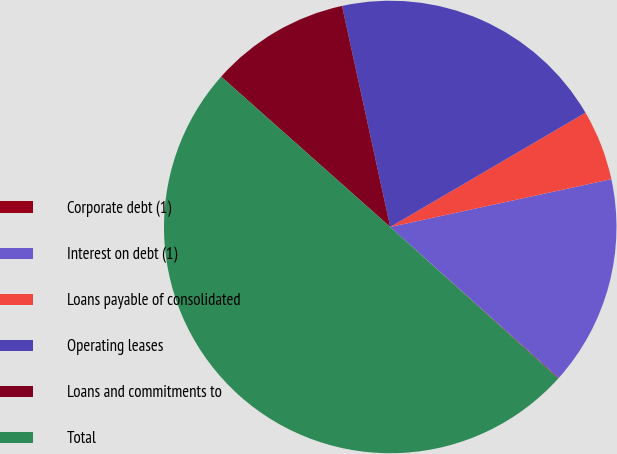<chart> <loc_0><loc_0><loc_500><loc_500><pie_chart><fcel>Corporate debt (1)<fcel>Interest on debt (1)<fcel>Loans payable of consolidated<fcel>Operating leases<fcel>Loans and commitments to<fcel>Total<nl><fcel>0.05%<fcel>15.01%<fcel>5.04%<fcel>19.99%<fcel>10.02%<fcel>49.9%<nl></chart> 